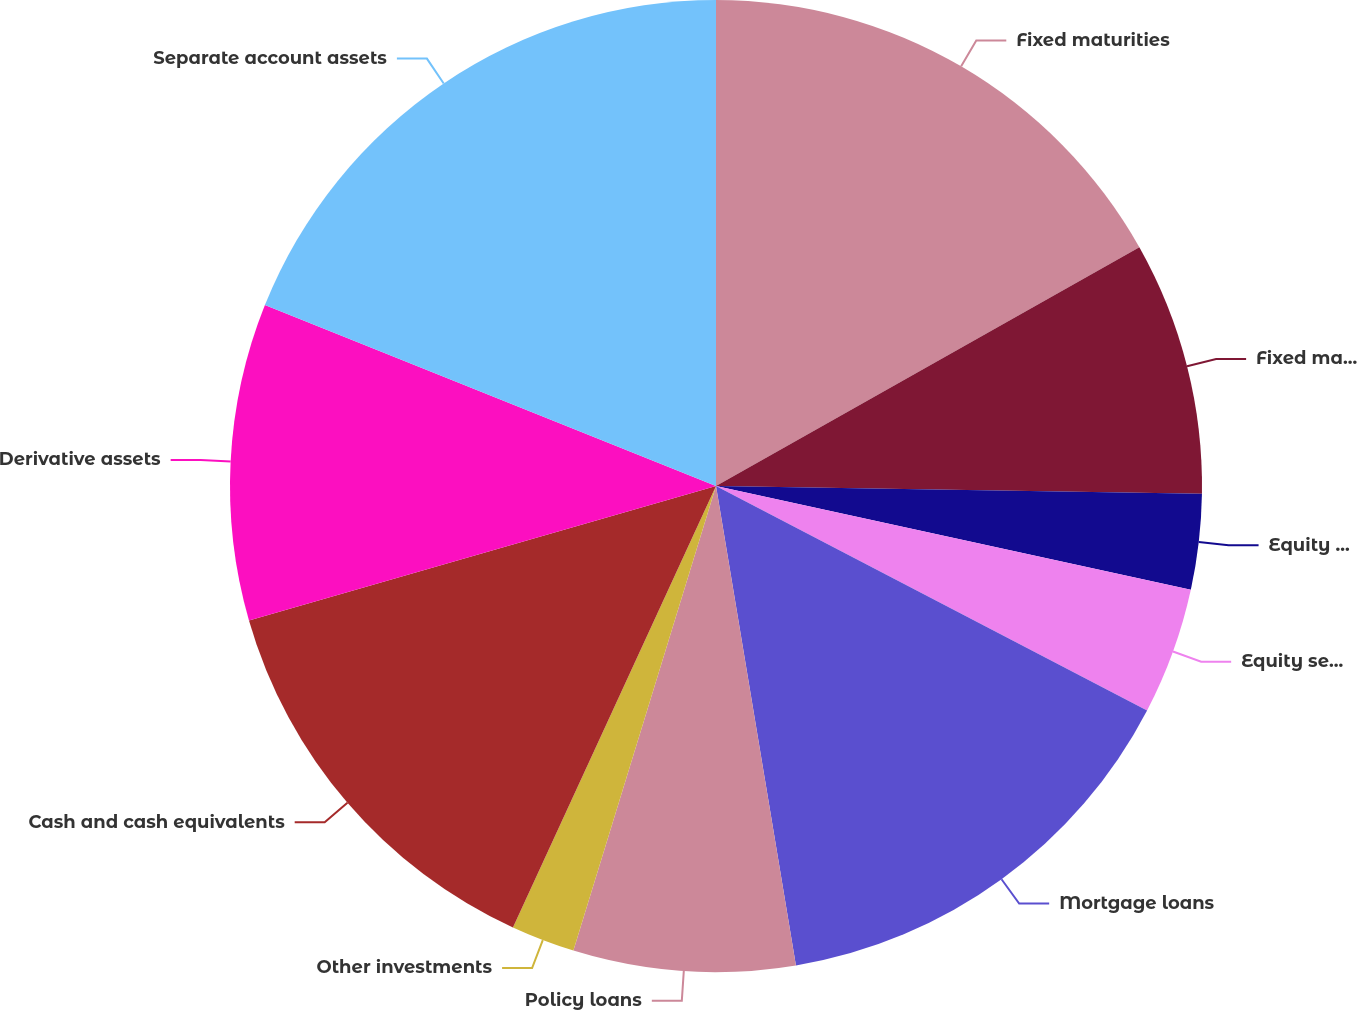Convert chart to OTSL. <chart><loc_0><loc_0><loc_500><loc_500><pie_chart><fcel>Fixed maturities<fcel>Fixed maturities trading<fcel>Equity securities<fcel>Equity securities trading<fcel>Mortgage loans<fcel>Policy loans<fcel>Other investments<fcel>Cash and cash equivalents<fcel>Derivative assets<fcel>Separate account assets<nl><fcel>16.83%<fcel>8.42%<fcel>3.17%<fcel>4.22%<fcel>14.73%<fcel>7.37%<fcel>2.12%<fcel>13.68%<fcel>10.53%<fcel>18.93%<nl></chart> 